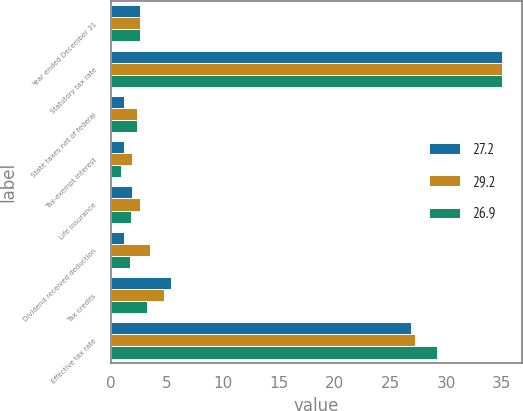<chart> <loc_0><loc_0><loc_500><loc_500><stacked_bar_chart><ecel><fcel>Year ended December 31<fcel>Statutory tax rate<fcel>State taxes net of federal<fcel>Tax-exempt interest<fcel>Life insurance<fcel>Dividend received deduction<fcel>Tax credits<fcel>Effective tax rate<nl><fcel>27.2<fcel>2.6<fcel>35<fcel>1.2<fcel>1.2<fcel>1.9<fcel>1.2<fcel>5.4<fcel>26.9<nl><fcel>29.2<fcel>2.6<fcel>35<fcel>2.3<fcel>1.9<fcel>2.6<fcel>3.5<fcel>4.8<fcel>27.2<nl><fcel>26.9<fcel>2.6<fcel>35<fcel>2.3<fcel>0.9<fcel>1.8<fcel>1.7<fcel>3.2<fcel>29.2<nl></chart> 